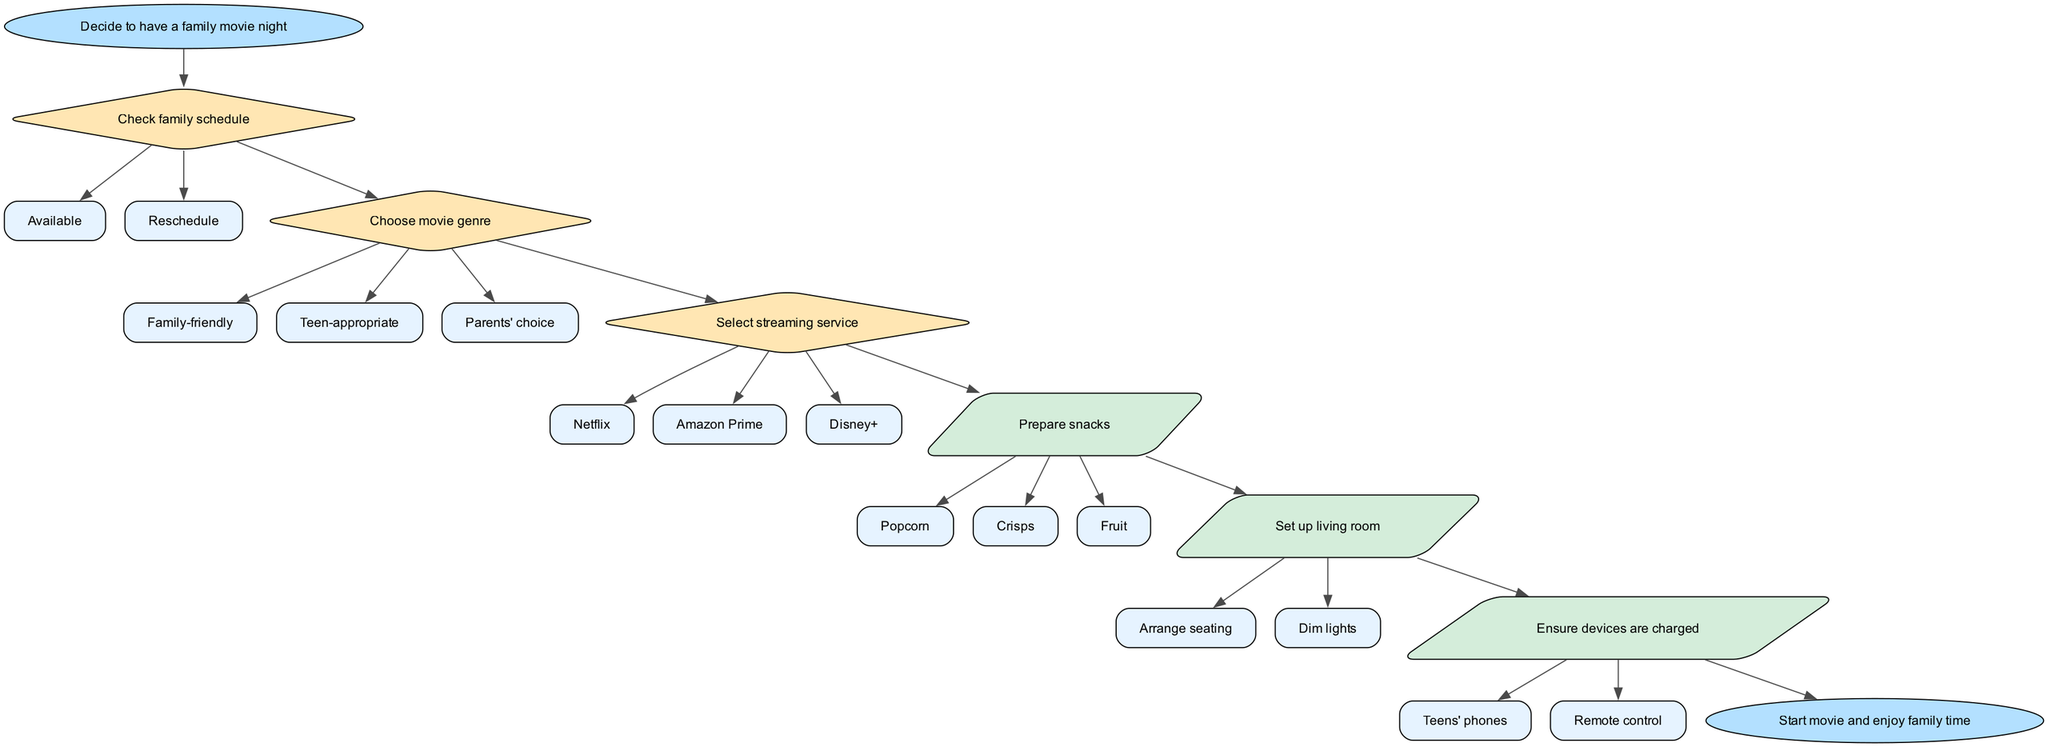What is the starting point of the flow chart? The starting point is labeled "Decide to have a family movie night." This is the node that initiates the process represented in the diagram.
Answer: Decide to have a family movie night How many decision nodes are there in the diagram? The diagram contains three decision nodes: "Check family schedule," "Choose movie genre," and "Select streaming service." Therefore, the total number is three.
Answer: 3 What snack options are available under the "Prepare snacks" action? The options listed under the "Prepare snacks" action are "Popcorn," "Crisps," and "Fruit." These represent the different snacks that can be prepared for the movie night.
Answer: Popcorn, Crisps, Fruit Which streaming services can be selected in the "Select streaming service" decision? The streaming services available are "Netflix," "Amazon Prime," and "Disney+." Each represents a choice for watching the movie.
Answer: Netflix, Amazon Prime, Disney+ What action follows the decision node "Choose movie genre"? After the "Choose movie genre" decision node, the next action node is "Select streaming service." This indicates that selecting the streaming service comes after the movie genre has been chosen.
Answer: Select streaming service If the family schedule is "Reschedule," which node does the flow lead to? If the family schedule results in "Reschedule," it means the family cannot proceed with the initial plan. However, the flow chart does not specify where to go from there. Thus, the diagram ends up leading to no further actions or decisions specified within this context.
Answer: No further actions specified What is the last step in the movie night flow process? The last step in the process is labeled "Start movie and enjoy family time." This highlights the final outcome after completing the prior actions.
Answer: Start movie and enjoy family time Which snack option comes first when preparing snacks? The first listed snack option is "Popcorn," as it appears first in the action node "Prepare snacks." This indicates a priority or common preference for movie snack.
Answer: Popcorn How do the action nodes relate to the decision nodes? The action nodes are linked sequentially after decision nodes are made. For example, after making decisions about the family schedule and movie genre, the actions of preparing snacks and setting up the living room follow logically. The flow shows a logical progression from decision-making to actions.
Answer: Sequentially linked 